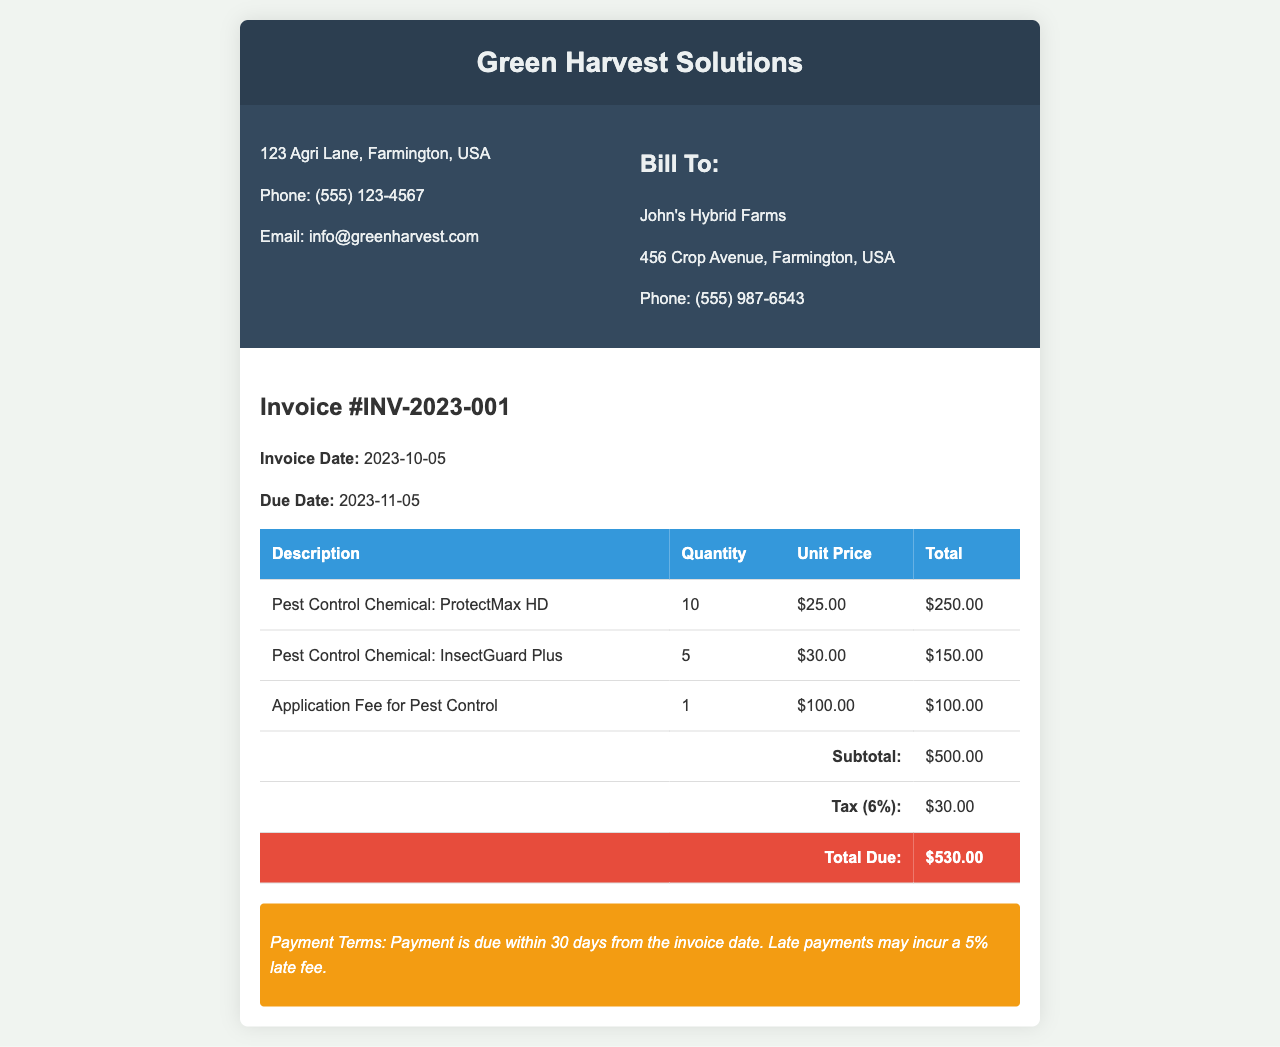what is the invoice number? The invoice number is located in the header section of the document as invoice #INV-2023-001.
Answer: INV-2023-001 what is the due date for this invoice? The due date is specified in the invoice details section and is listed as 2023-11-05.
Answer: 2023-11-05 how many Pest Control Chemicals were ordered? The total quantity of Pest Control Chemicals ordered is the sum of the quantities listed for each item in the invoice, which is 10 + 5 = 15.
Answer: 15 what is the total amount due? The total amount due is clearly presented at the bottom of the invoice in the total row, which lists the amount as $530.00.
Answer: $530.00 how much is the application fee for pest control? The application fee is listed in the invoice under the description "Application Fee for Pest Control" and is stated as $100.00.
Answer: $100.00 what is the name of the pest control chemical with the highest unit price? The pest control chemical with the highest unit price is "InsectGuard Plus," with a unit price of $30.00.
Answer: InsectGuard Plus what is the tax rate applied to the invoice? The tax rate is given in the invoice as 6%, which is calculated based on the subtotal.
Answer: 6% who is the customer listed on the invoice? The customer name is provided in the "Bill To" section of the invoice, which states "John's Hybrid Farms."
Answer: John's Hybrid Farms what is the payment term mentioned in the invoice? The payment term is described at the bottom of the invoice, indicating that payment is due within 30 days from the invoice date.
Answer: 30 days 